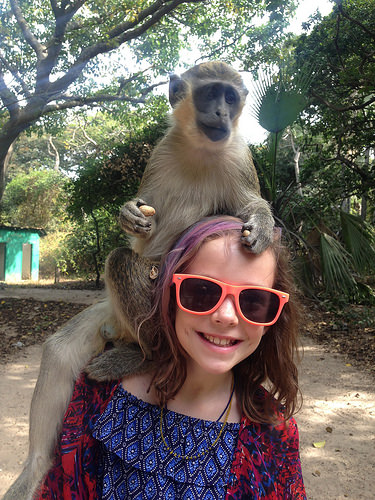<image>
Can you confirm if the girl is on the monkey? No. The girl is not positioned on the monkey. They may be near each other, but the girl is not supported by or resting on top of the monkey. 